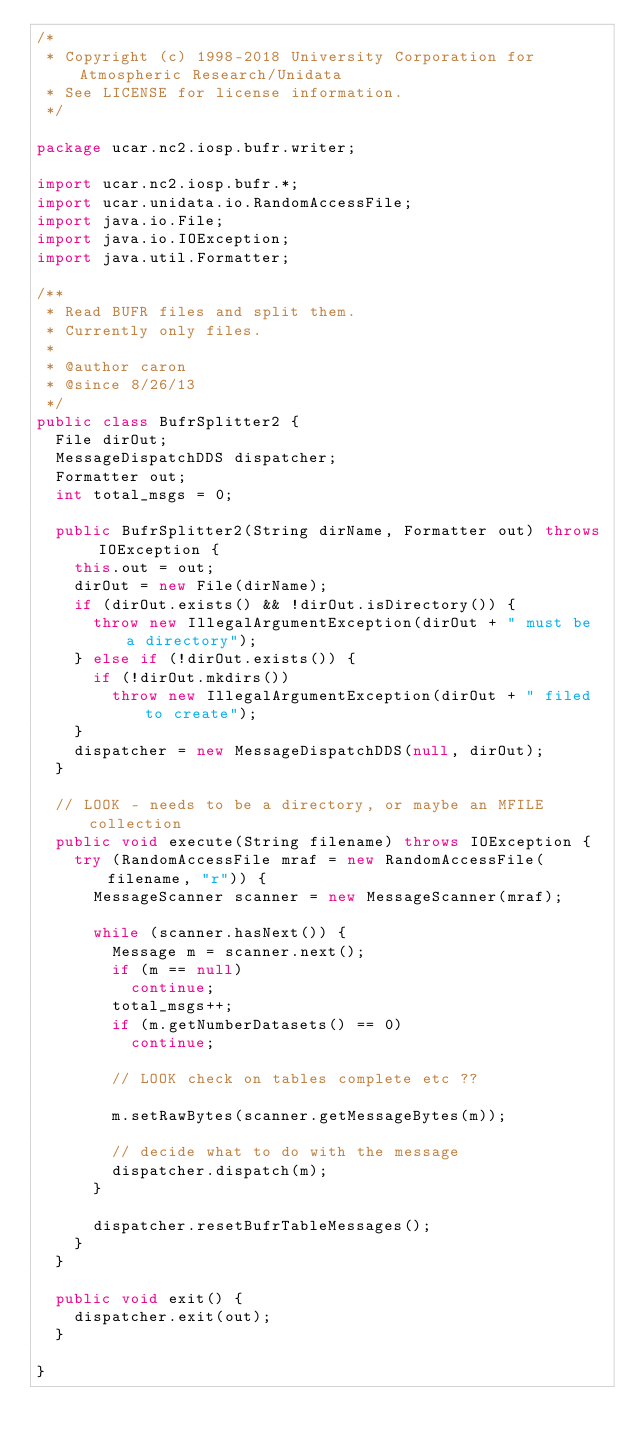<code> <loc_0><loc_0><loc_500><loc_500><_Java_>/*
 * Copyright (c) 1998-2018 University Corporation for Atmospheric Research/Unidata
 * See LICENSE for license information.
 */

package ucar.nc2.iosp.bufr.writer;

import ucar.nc2.iosp.bufr.*;
import ucar.unidata.io.RandomAccessFile;
import java.io.File;
import java.io.IOException;
import java.util.Formatter;

/**
 * Read BUFR files and split them.
 * Currently only files.
 *
 * @author caron
 * @since 8/26/13
 */
public class BufrSplitter2 {
  File dirOut;
  MessageDispatchDDS dispatcher;
  Formatter out;
  int total_msgs = 0;

  public BufrSplitter2(String dirName, Formatter out) throws IOException {
    this.out = out;
    dirOut = new File(dirName);
    if (dirOut.exists() && !dirOut.isDirectory()) {
      throw new IllegalArgumentException(dirOut + " must be a directory");
    } else if (!dirOut.exists()) {
      if (!dirOut.mkdirs())
        throw new IllegalArgumentException(dirOut + " filed to create");
    }
    dispatcher = new MessageDispatchDDS(null, dirOut);
  }

  // LOOK - needs to be a directory, or maybe an MFILE collection
  public void execute(String filename) throws IOException {
    try (RandomAccessFile mraf = new RandomAccessFile(filename, "r")) {
      MessageScanner scanner = new MessageScanner(mraf);

      while (scanner.hasNext()) {
        Message m = scanner.next();
        if (m == null)
          continue;
        total_msgs++;
        if (m.getNumberDatasets() == 0)
          continue;

        // LOOK check on tables complete etc ??

        m.setRawBytes(scanner.getMessageBytes(m));

        // decide what to do with the message
        dispatcher.dispatch(m);
      }

      dispatcher.resetBufrTableMessages();
    }
  }

  public void exit() {
    dispatcher.exit(out);
  }

}
</code> 